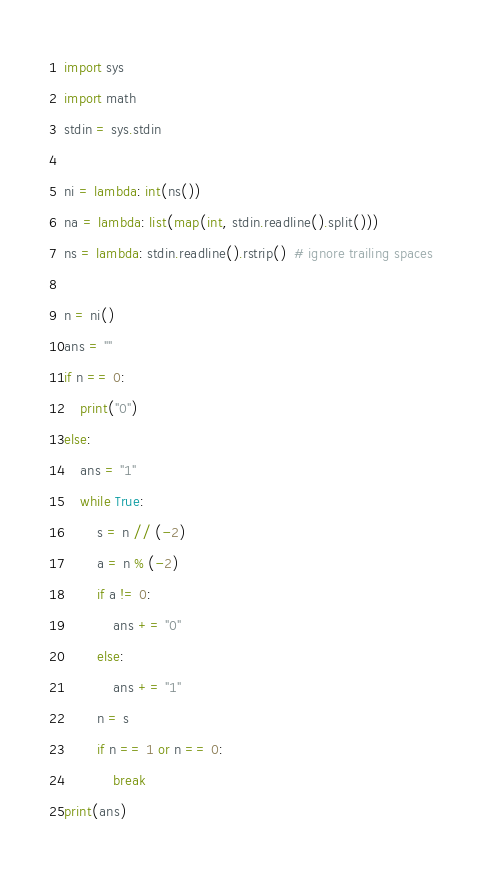Convert code to text. <code><loc_0><loc_0><loc_500><loc_500><_Python_>import sys
import math
stdin = sys.stdin

ni = lambda: int(ns())
na = lambda: list(map(int, stdin.readline().split()))
ns = lambda: stdin.readline().rstrip()  # ignore trailing spaces

n = ni()
ans = ""
if n == 0:
    print("0")
else:
    ans = "1"
    while True:
        s = n // (-2)
        a = n % (-2)
        if a != 0:
            ans += "0"
        else:
            ans += "1"
        n = s
        if n == 1 or n == 0:
            break
print(ans)

</code> 